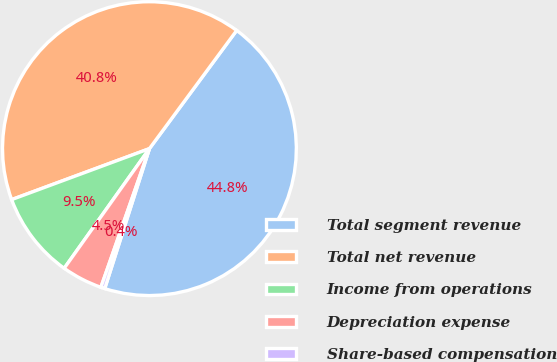Convert chart. <chart><loc_0><loc_0><loc_500><loc_500><pie_chart><fcel>Total segment revenue<fcel>Total net revenue<fcel>Income from operations<fcel>Depreciation expense<fcel>Share-based compensation<nl><fcel>44.8%<fcel>40.76%<fcel>9.51%<fcel>4.49%<fcel>0.44%<nl></chart> 